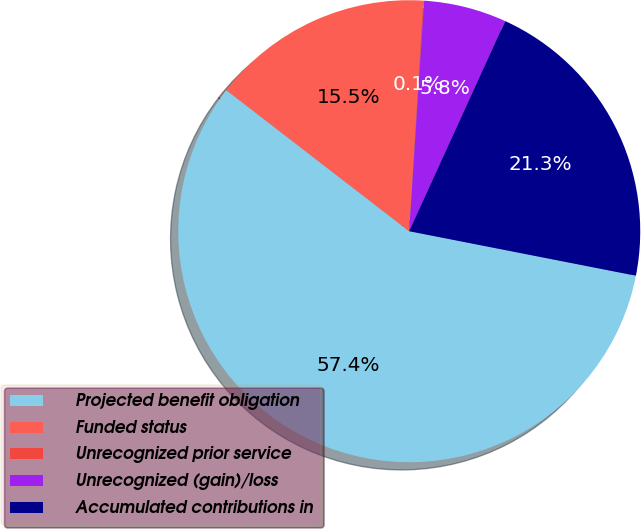<chart> <loc_0><loc_0><loc_500><loc_500><pie_chart><fcel>Projected benefit obligation<fcel>Funded status<fcel>Unrecognized prior service<fcel>Unrecognized (gain)/loss<fcel>Accumulated contributions in<nl><fcel>57.37%<fcel>15.51%<fcel>0.06%<fcel>5.79%<fcel>21.27%<nl></chart> 